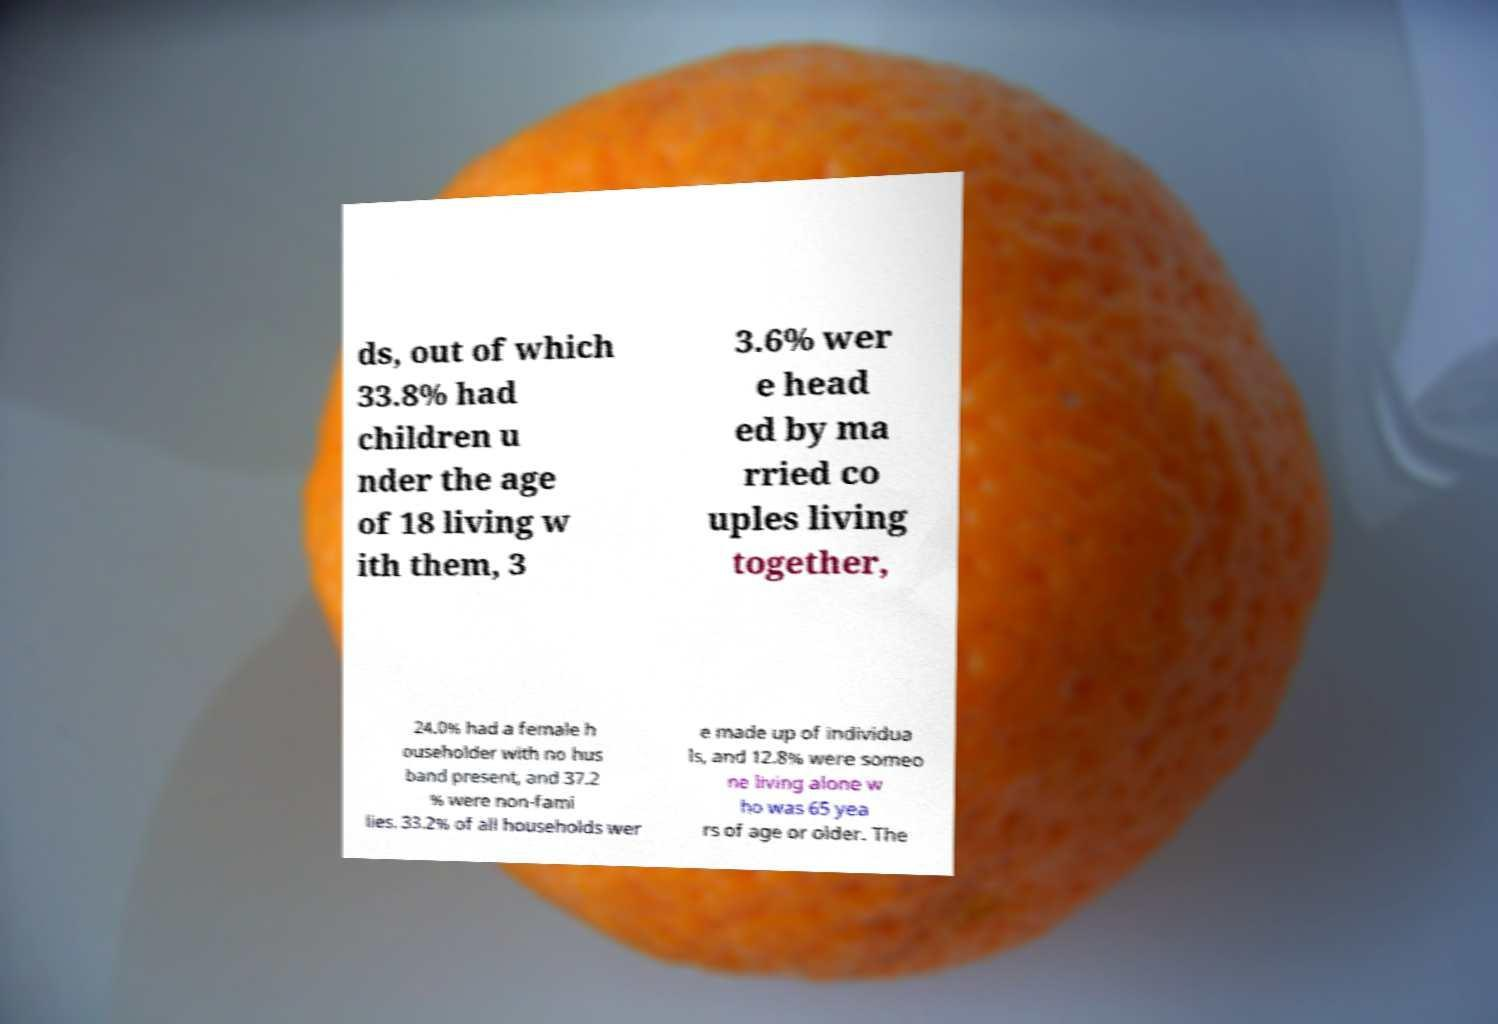Could you assist in decoding the text presented in this image and type it out clearly? ds, out of which 33.8% had children u nder the age of 18 living w ith them, 3 3.6% wer e head ed by ma rried co uples living together, 24.0% had a female h ouseholder with no hus band present, and 37.2 % were non-fami lies. 33.2% of all households wer e made up of individua ls, and 12.8% were someo ne living alone w ho was 65 yea rs of age or older. The 